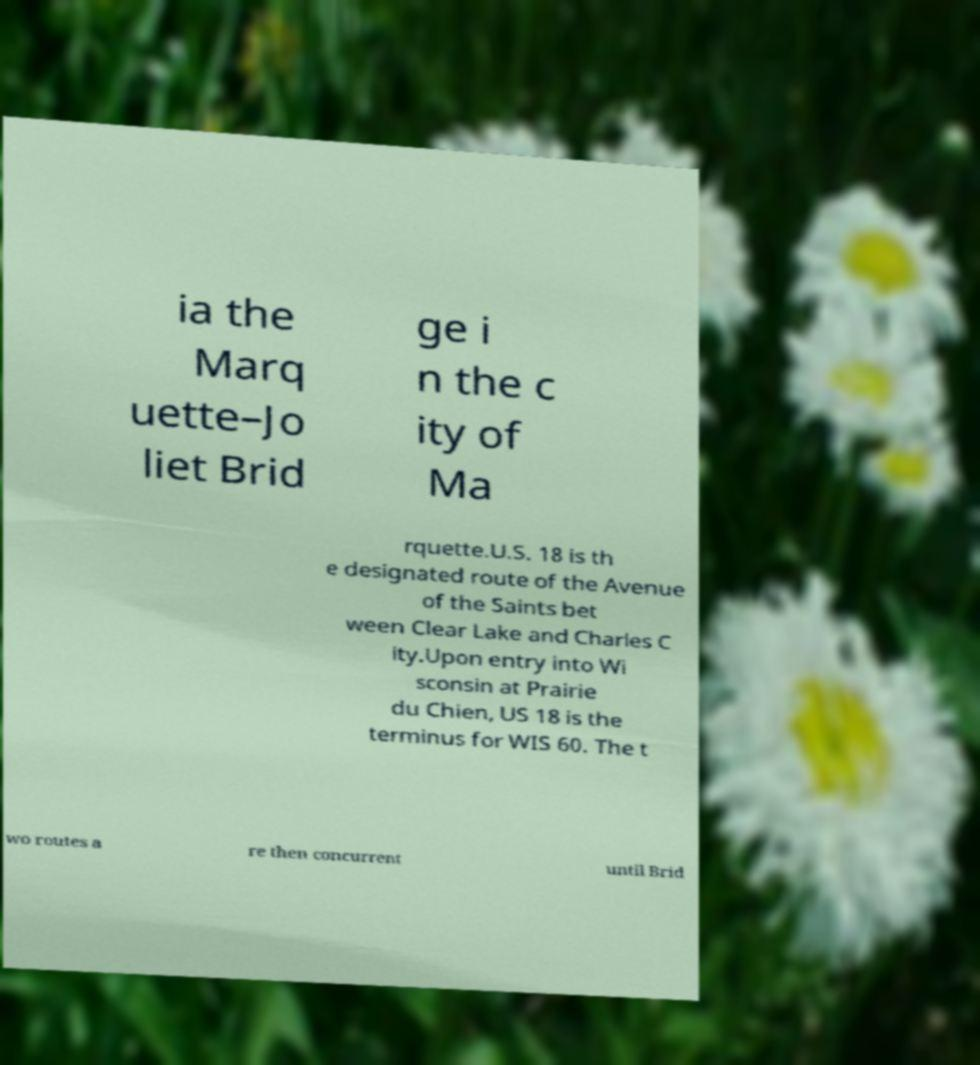Can you read and provide the text displayed in the image?This photo seems to have some interesting text. Can you extract and type it out for me? ia the Marq uette–Jo liet Brid ge i n the c ity of Ma rquette.U.S. 18 is th e designated route of the Avenue of the Saints bet ween Clear Lake and Charles C ity.Upon entry into Wi sconsin at Prairie du Chien, US 18 is the terminus for WIS 60. The t wo routes a re then concurrent until Brid 